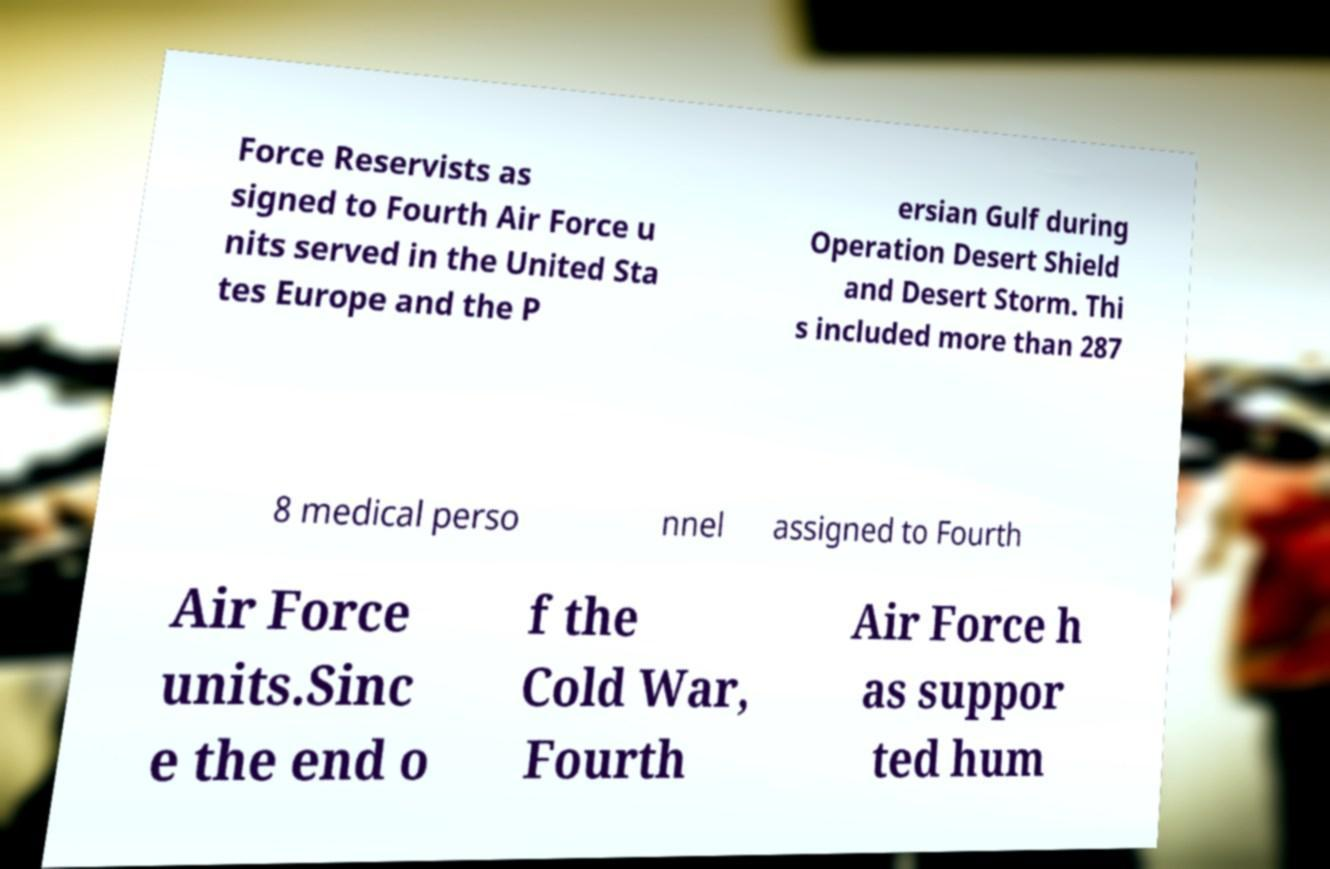There's text embedded in this image that I need extracted. Can you transcribe it verbatim? Force Reservists as signed to Fourth Air Force u nits served in the United Sta tes Europe and the P ersian Gulf during Operation Desert Shield and Desert Storm. Thi s included more than 287 8 medical perso nnel assigned to Fourth Air Force units.Sinc e the end o f the Cold War, Fourth Air Force h as suppor ted hum 